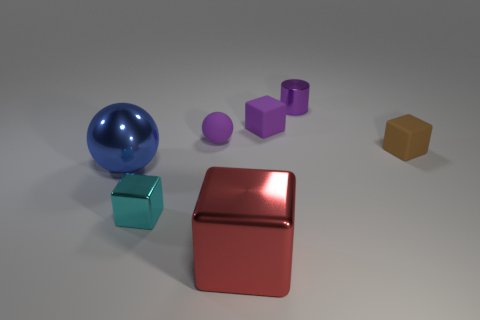Subtract all red cylinders. Subtract all yellow cubes. How many cylinders are left? 1 Subtract all cyan blocks. How many blue cylinders are left? 0 Add 3 things. How many purples exist? 0 Subtract all purple blocks. Subtract all blue spheres. How many objects are left? 5 Add 4 big metallic blocks. How many big metallic blocks are left? 5 Add 1 red metallic cylinders. How many red metallic cylinders exist? 1 Add 1 brown rubber things. How many objects exist? 8 Subtract all cyan blocks. How many blocks are left? 3 Subtract all brown rubber cubes. How many cubes are left? 3 Subtract 0 brown cylinders. How many objects are left? 7 